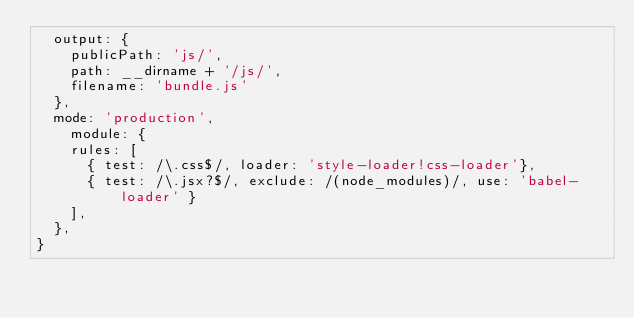<code> <loc_0><loc_0><loc_500><loc_500><_JavaScript_>  output: {
    publicPath: 'js/',
    path: __dirname + '/js/',
    filename: 'bundle.js'
  },
  mode: 'production',
    module: {
    rules: [
      { test: /\.css$/, loader: 'style-loader!css-loader'},
      { test: /\.jsx?$/, exclude: /(node_modules)/, use: 'babel-loader' }
    ],    
  },  
}</code> 